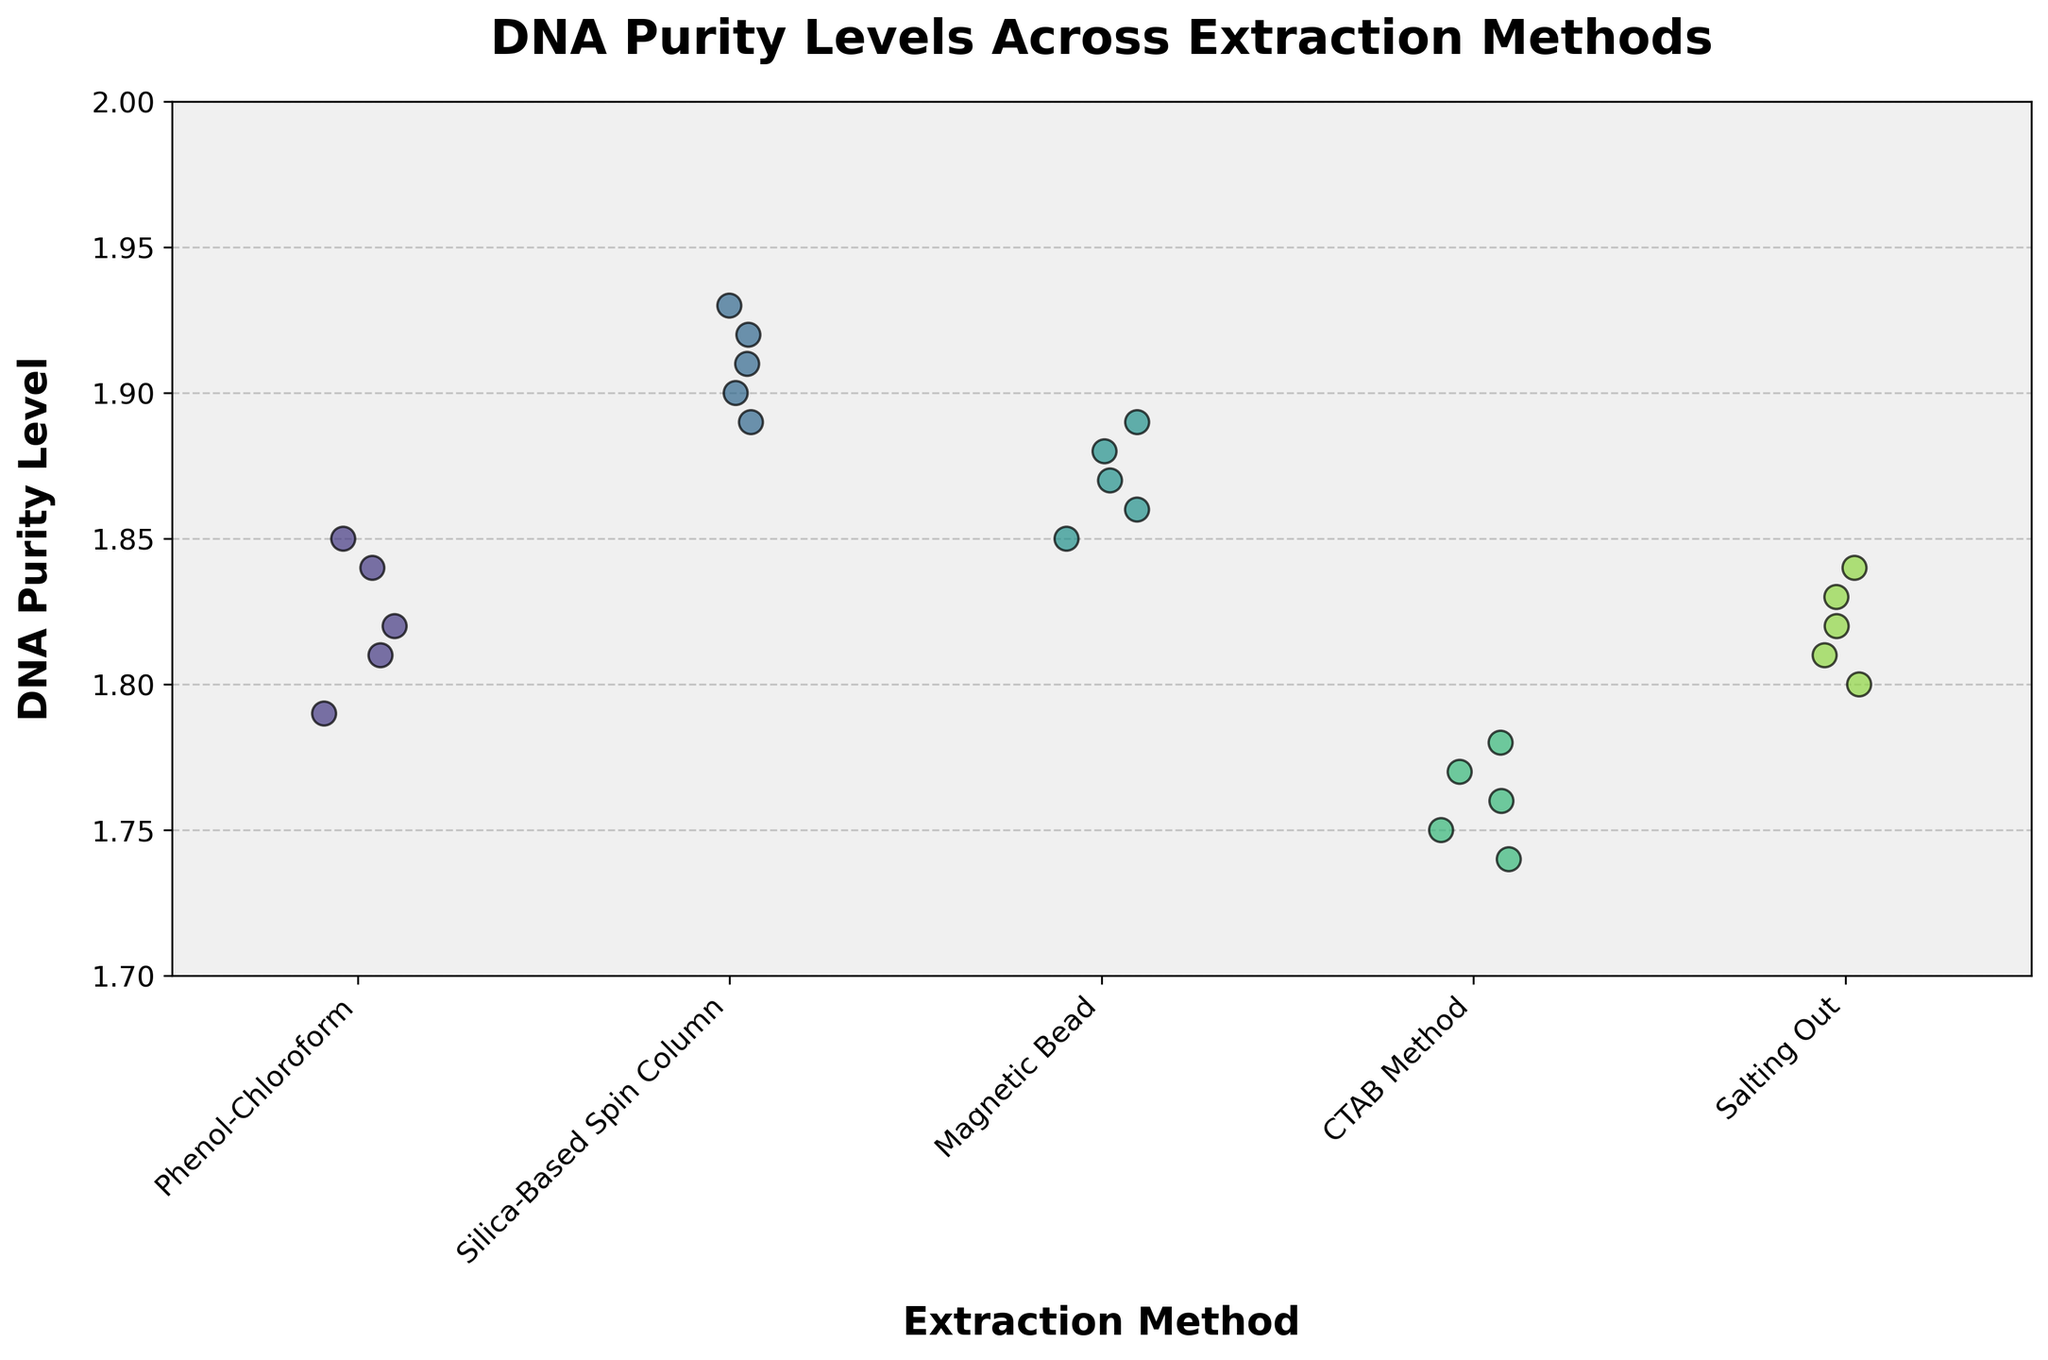What is the title of the plot? The title of the plot is usually located at the top center of the figure.
Answer: DNA Purity Levels Across Extraction Methods What is the maximum DNA purity level observed in the 'CTAB Method' extraction method? Locate the dots corresponding to the 'CTAB Method' on the x-axis. The highest dot represents the maximum DNA purity level.
Answer: 1.78 Which extraction method has the highest average DNA purity level? Visually estimate the average position of the dots for each extraction method. The 'Silica-Based Spin Column' has the highest average dot positions.
Answer: Silica-Based Spin Column How many data points are there for the 'Phenol-Chloroform' extraction method? Count the number of individual data points (dots) above the 'Phenol-Chloroform' label on the x-axis.
Answer: 5 Compare the DNA purity levels of 'Magnetic Bead' and 'Salting Out'. Which one generally has higher DNA purity levels? Visually compare the distribution of dots for 'Magnetic Bead' and 'Salting Out'. The dots for 'Magnetic Bead' are generally higher.
Answer: Magnetic Bead What is the range of DNA purity levels for 'Silica-Based Spin Column'? Find the lowest and highest dots for 'Silica-Based Spin Column', then calculate the difference. The range is from 1.89 to 1.93 (1.93 - 1.89).
Answer: 0.04 Are there any overlapping DNA purity levels between 'Phenol-Chloroform' and 'Salting Out'? Check if any dots at the same y-axis level appear in both 'Phenol-Chloroform' and 'Salting Out' columns. Both have dots at 1.84, 1.82, and 1.81.
Answer: Yes Which extraction method shows the least variability in DNA purity levels? Look for the extraction method with the smallest spread of dots on the y-axis. 'Silica-Based Spin Column' seems to show the least variability.
Answer: Silica-Based Spin Column 